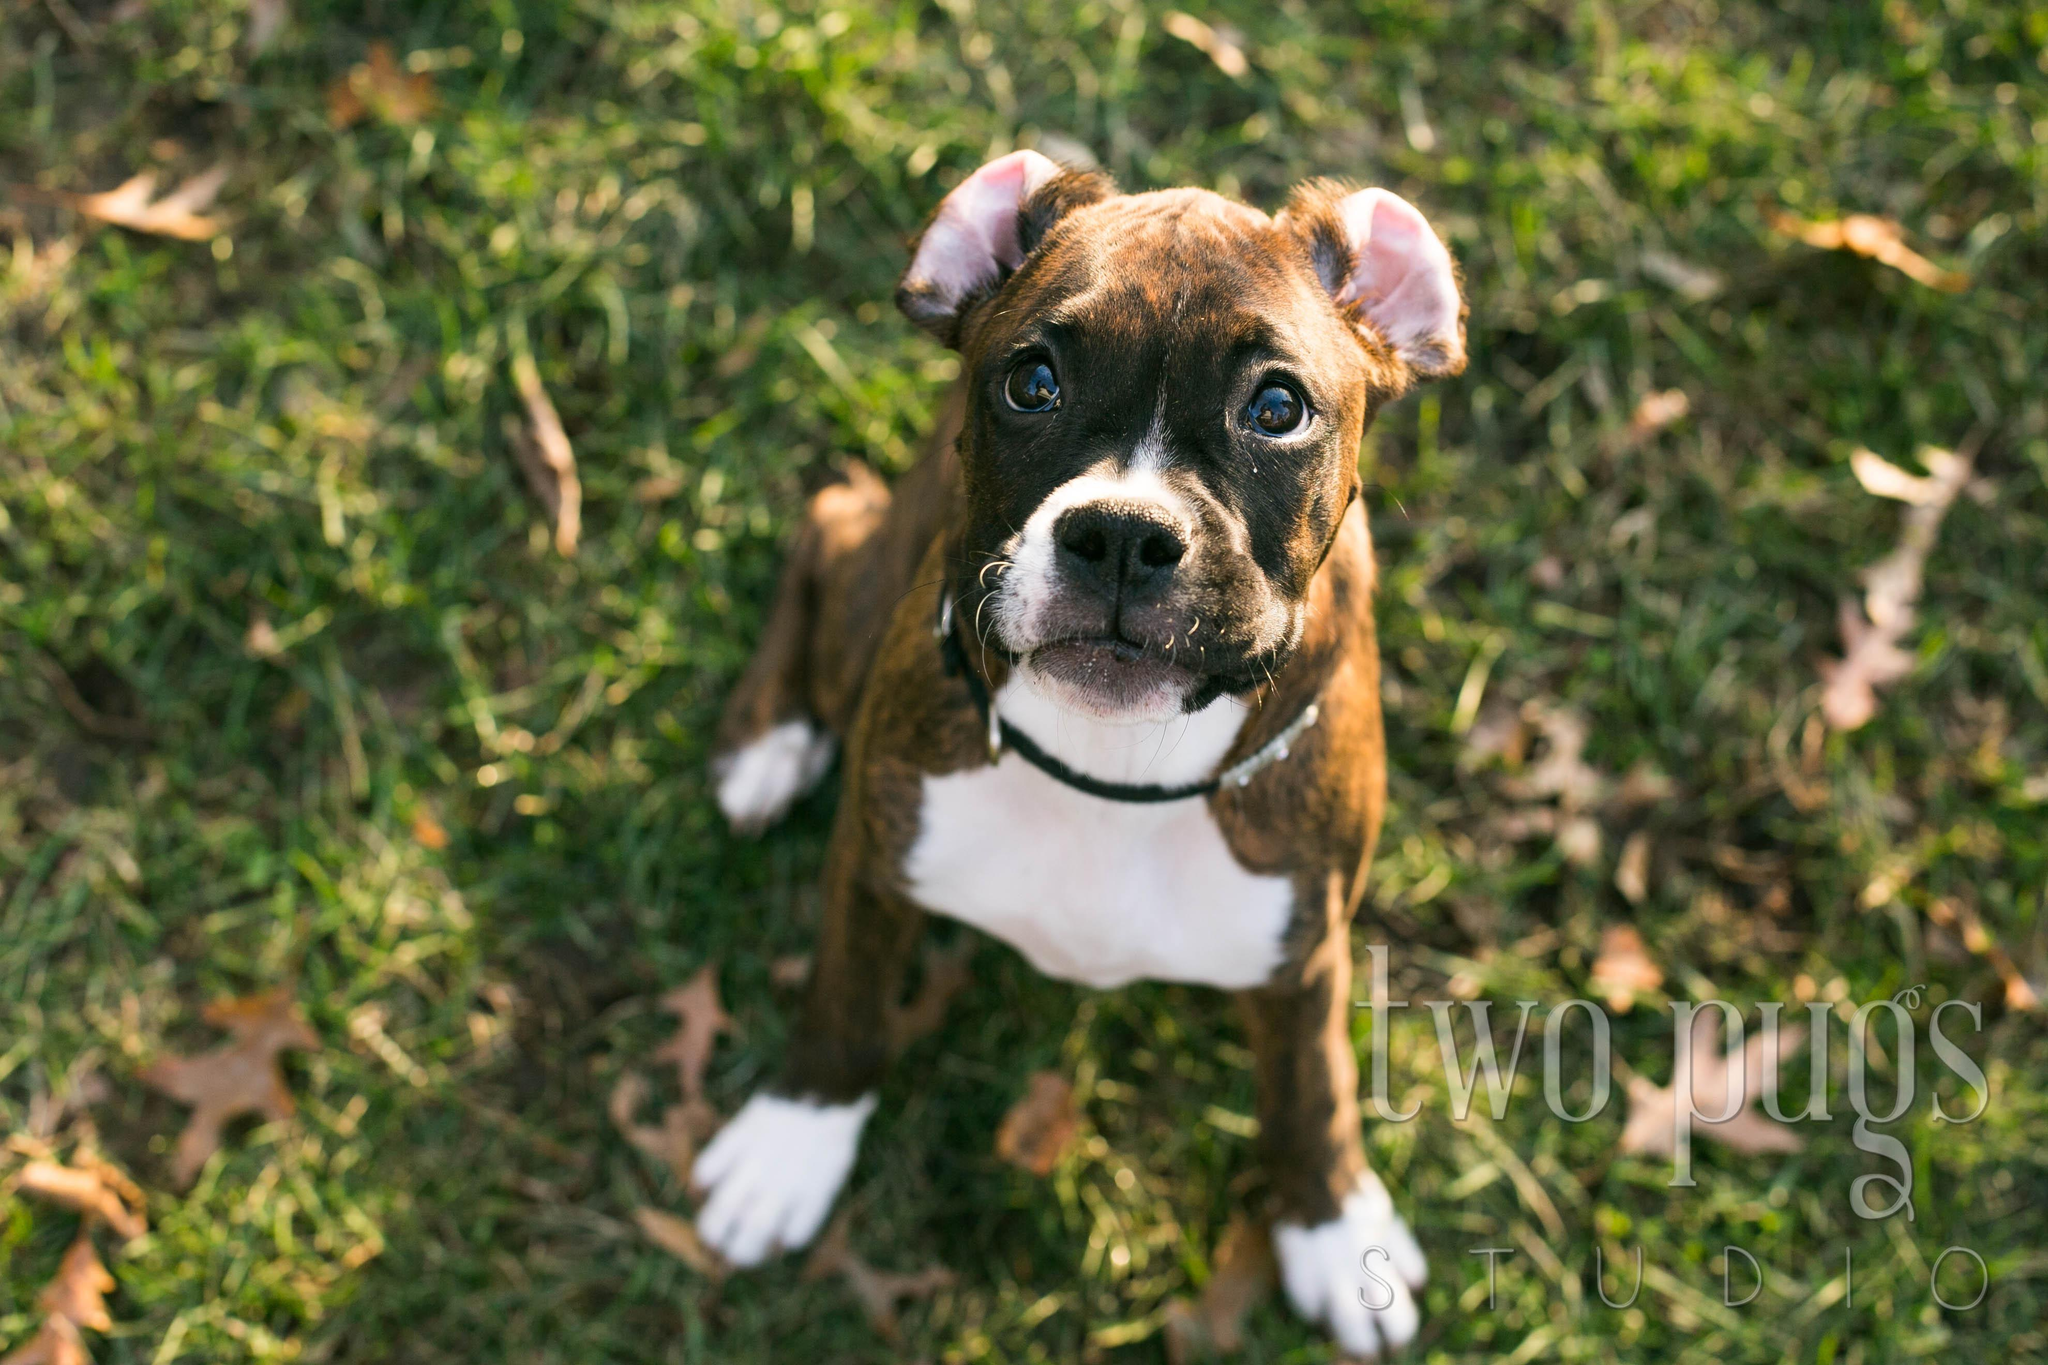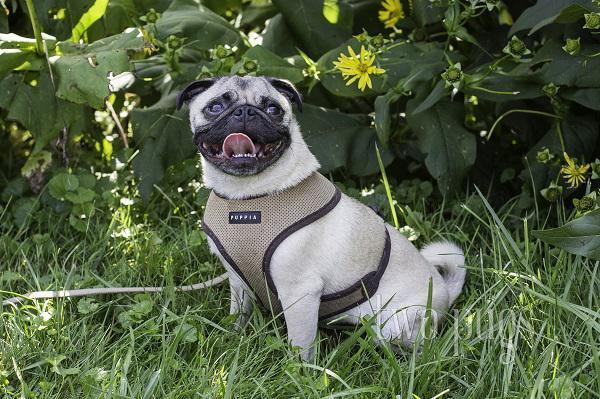The first image is the image on the left, the second image is the image on the right. Evaluate the accuracy of this statement regarding the images: "The dog in the right image is wearing a harness.". Is it true? Answer yes or no. Yes. The first image is the image on the left, the second image is the image on the right. Examine the images to the left and right. Is the description "There is one bird next to a dog." accurate? Answer yes or no. No. 